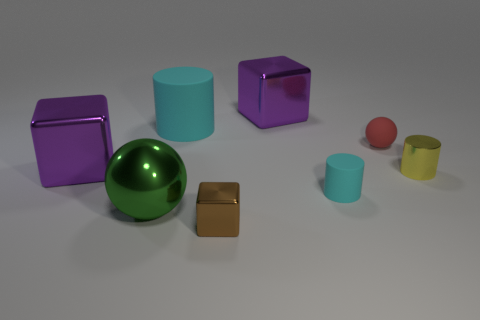What is the material of the small cylinder that is the same color as the large cylinder? Based on the image, the small cylinder sharing the same vibrant teal color as the large cylinder appears to be made of a matte plastic. This judgement is made by observing the light reflection and surface texture, which are consistent with common plastic materials seen in everyday objects. 